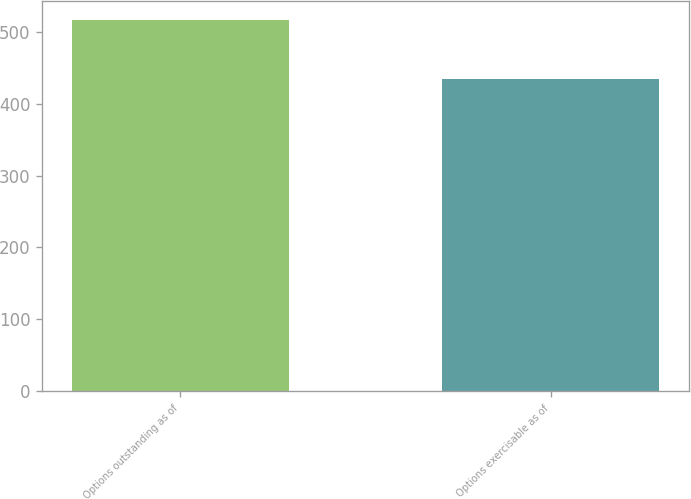Convert chart to OTSL. <chart><loc_0><loc_0><loc_500><loc_500><bar_chart><fcel>Options outstanding as of<fcel>Options exercisable as of<nl><fcel>517<fcel>434<nl></chart> 